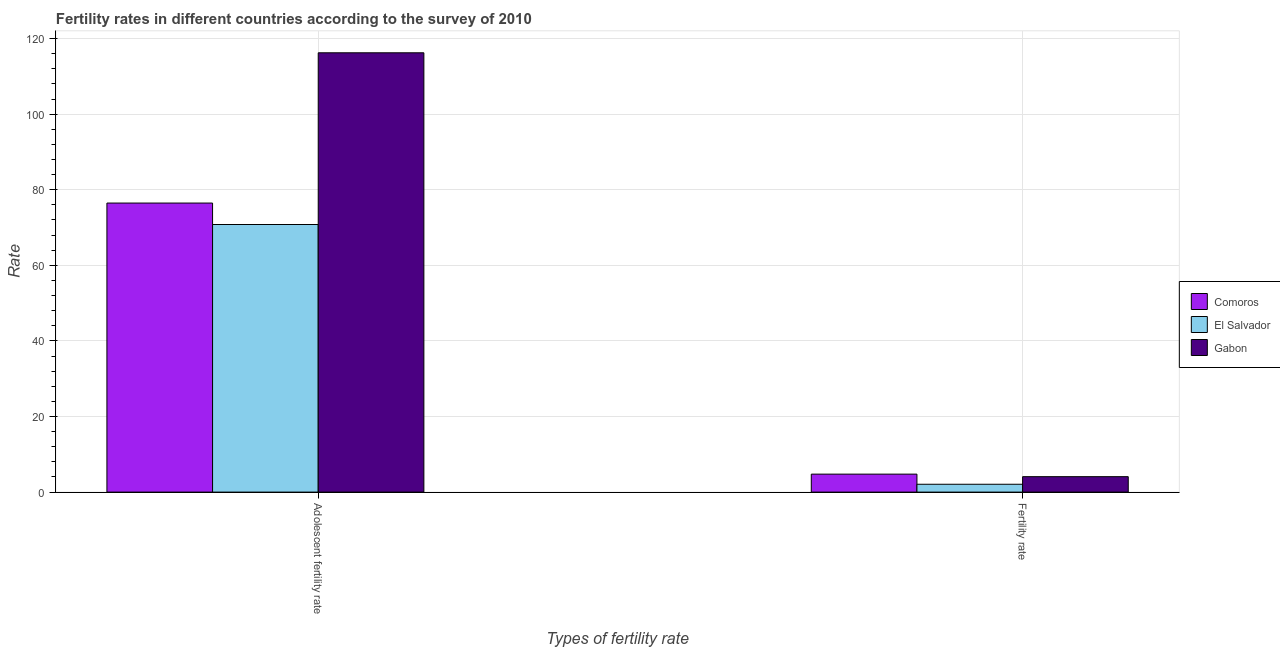What is the label of the 2nd group of bars from the left?
Keep it short and to the point. Fertility rate. What is the fertility rate in Comoros?
Your answer should be compact. 4.75. Across all countries, what is the maximum fertility rate?
Your response must be concise. 4.75. Across all countries, what is the minimum fertility rate?
Give a very brief answer. 2.08. In which country was the fertility rate maximum?
Offer a terse response. Comoros. In which country was the fertility rate minimum?
Offer a very short reply. El Salvador. What is the total fertility rate in the graph?
Your response must be concise. 10.92. What is the difference between the fertility rate in Gabon and that in El Salvador?
Offer a very short reply. 2.01. What is the difference between the fertility rate in El Salvador and the adolescent fertility rate in Gabon?
Offer a terse response. -114.15. What is the average adolescent fertility rate per country?
Your response must be concise. 87.83. What is the difference between the fertility rate and adolescent fertility rate in Gabon?
Give a very brief answer. -112.14. What is the ratio of the fertility rate in El Salvador to that in Gabon?
Your answer should be very brief. 0.51. What does the 2nd bar from the left in Adolescent fertility rate represents?
Provide a short and direct response. El Salvador. What does the 2nd bar from the right in Adolescent fertility rate represents?
Provide a succinct answer. El Salvador. What is the difference between two consecutive major ticks on the Y-axis?
Provide a succinct answer. 20. Are the values on the major ticks of Y-axis written in scientific E-notation?
Make the answer very short. No. Does the graph contain any zero values?
Ensure brevity in your answer.  No. Does the graph contain grids?
Your answer should be very brief. Yes. Where does the legend appear in the graph?
Ensure brevity in your answer.  Center right. How many legend labels are there?
Offer a very short reply. 3. How are the legend labels stacked?
Offer a very short reply. Vertical. What is the title of the graph?
Provide a succinct answer. Fertility rates in different countries according to the survey of 2010. Does "Cayman Islands" appear as one of the legend labels in the graph?
Your answer should be very brief. No. What is the label or title of the X-axis?
Ensure brevity in your answer.  Types of fertility rate. What is the label or title of the Y-axis?
Your response must be concise. Rate. What is the Rate in Comoros in Adolescent fertility rate?
Provide a short and direct response. 76.47. What is the Rate of El Salvador in Adolescent fertility rate?
Ensure brevity in your answer.  70.8. What is the Rate in Gabon in Adolescent fertility rate?
Your answer should be very brief. 116.23. What is the Rate of Comoros in Fertility rate?
Provide a succinct answer. 4.75. What is the Rate of El Salvador in Fertility rate?
Ensure brevity in your answer.  2.08. What is the Rate of Gabon in Fertility rate?
Give a very brief answer. 4.08. Across all Types of fertility rate, what is the maximum Rate in Comoros?
Offer a very short reply. 76.47. Across all Types of fertility rate, what is the maximum Rate in El Salvador?
Provide a short and direct response. 70.8. Across all Types of fertility rate, what is the maximum Rate of Gabon?
Provide a short and direct response. 116.23. Across all Types of fertility rate, what is the minimum Rate in Comoros?
Provide a succinct answer. 4.75. Across all Types of fertility rate, what is the minimum Rate of El Salvador?
Your answer should be compact. 2.08. Across all Types of fertility rate, what is the minimum Rate of Gabon?
Offer a very short reply. 4.08. What is the total Rate of Comoros in the graph?
Provide a short and direct response. 81.23. What is the total Rate of El Salvador in the graph?
Give a very brief answer. 72.88. What is the total Rate of Gabon in the graph?
Your answer should be compact. 120.31. What is the difference between the Rate in Comoros in Adolescent fertility rate and that in Fertility rate?
Make the answer very short. 71.72. What is the difference between the Rate in El Salvador in Adolescent fertility rate and that in Fertility rate?
Give a very brief answer. 68.72. What is the difference between the Rate of Gabon in Adolescent fertility rate and that in Fertility rate?
Ensure brevity in your answer.  112.14. What is the difference between the Rate of Comoros in Adolescent fertility rate and the Rate of El Salvador in Fertility rate?
Ensure brevity in your answer.  74.4. What is the difference between the Rate in Comoros in Adolescent fertility rate and the Rate in Gabon in Fertility rate?
Make the answer very short. 72.39. What is the difference between the Rate in El Salvador in Adolescent fertility rate and the Rate in Gabon in Fertility rate?
Give a very brief answer. 66.71. What is the average Rate of Comoros per Types of fertility rate?
Your answer should be compact. 40.61. What is the average Rate in El Salvador per Types of fertility rate?
Offer a terse response. 36.44. What is the average Rate of Gabon per Types of fertility rate?
Offer a very short reply. 60.16. What is the difference between the Rate of Comoros and Rate of El Salvador in Adolescent fertility rate?
Offer a very short reply. 5.68. What is the difference between the Rate of Comoros and Rate of Gabon in Adolescent fertility rate?
Provide a short and direct response. -39.75. What is the difference between the Rate of El Salvador and Rate of Gabon in Adolescent fertility rate?
Your response must be concise. -45.43. What is the difference between the Rate of Comoros and Rate of El Salvador in Fertility rate?
Provide a succinct answer. 2.68. What is the difference between the Rate of Comoros and Rate of Gabon in Fertility rate?
Your answer should be compact. 0.67. What is the difference between the Rate in El Salvador and Rate in Gabon in Fertility rate?
Give a very brief answer. -2. What is the ratio of the Rate in Comoros in Adolescent fertility rate to that in Fertility rate?
Offer a terse response. 16.08. What is the ratio of the Rate in El Salvador in Adolescent fertility rate to that in Fertility rate?
Your answer should be very brief. 34.07. What is the ratio of the Rate in Gabon in Adolescent fertility rate to that in Fertility rate?
Provide a short and direct response. 28.47. What is the difference between the highest and the second highest Rate of Comoros?
Give a very brief answer. 71.72. What is the difference between the highest and the second highest Rate of El Salvador?
Keep it short and to the point. 68.72. What is the difference between the highest and the second highest Rate in Gabon?
Offer a terse response. 112.14. What is the difference between the highest and the lowest Rate in Comoros?
Ensure brevity in your answer.  71.72. What is the difference between the highest and the lowest Rate in El Salvador?
Provide a short and direct response. 68.72. What is the difference between the highest and the lowest Rate of Gabon?
Offer a very short reply. 112.14. 